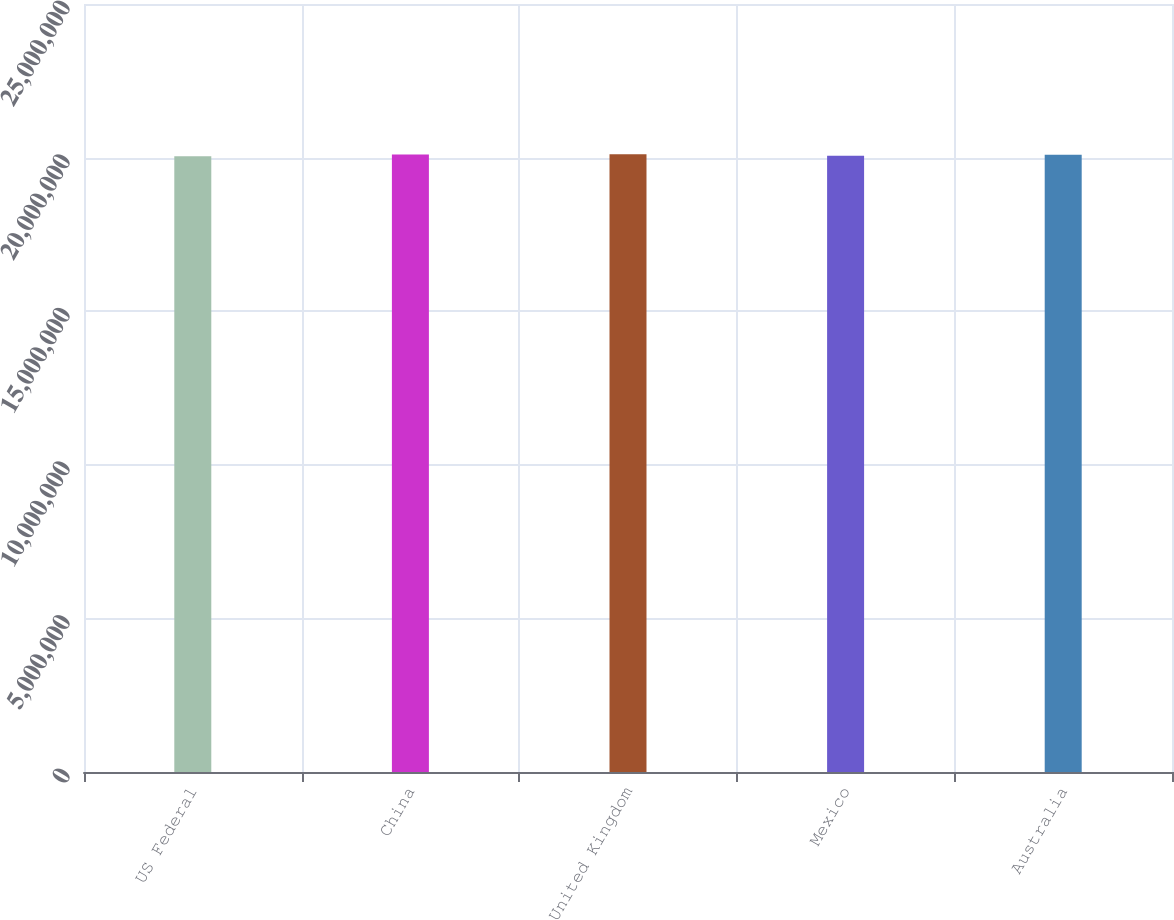<chart> <loc_0><loc_0><loc_500><loc_500><bar_chart><fcel>US Federal<fcel>China<fcel>United Kingdom<fcel>Mexico<fcel>Australia<nl><fcel>2.0042e+07<fcel>2.0102e+07<fcel>2.0108e+07<fcel>2.0062e+07<fcel>2.0092e+07<nl></chart> 